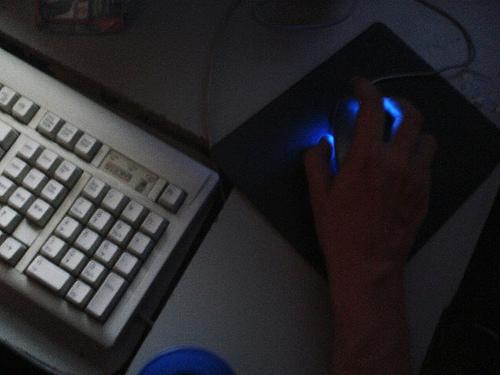Is this the left or right hand shown?
Short answer required. Right. How many colors can be seen on the keyboard?
Concise answer only. 2. What's the color of the mousepad?
Give a very brief answer. Black. Does it have any red buttons?
Give a very brief answer. No. Why is part of the computer in the shade?
Keep it brief. Light is off. What is the person holding in their hand?
Keep it brief. Mouse. How many times has the blue cord been wrapped?
Write a very short answer. 1. Is this person left or right handed?
Answer briefly. Right. Is the entire picture in focus?
Short answer required. No. Can this keyboard type?
Be succinct. Yes. How many color lights do you see?
Give a very brief answer. 1. Is the mouse wired or wireless?
Keep it brief. Wired. How many keys are on the keyboard?
Concise answer only. 37. 